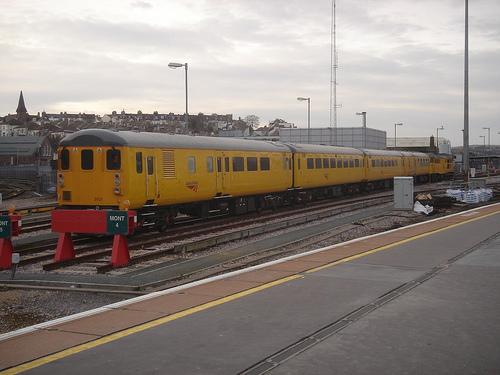What color is the train?
Be succinct. Yellow. What is the number on the sign?
Answer briefly. 4. Is this train moving?
Concise answer only. No. How many street poles?
Keep it brief. 9. Does the weather look threatening?
Keep it brief. No. 